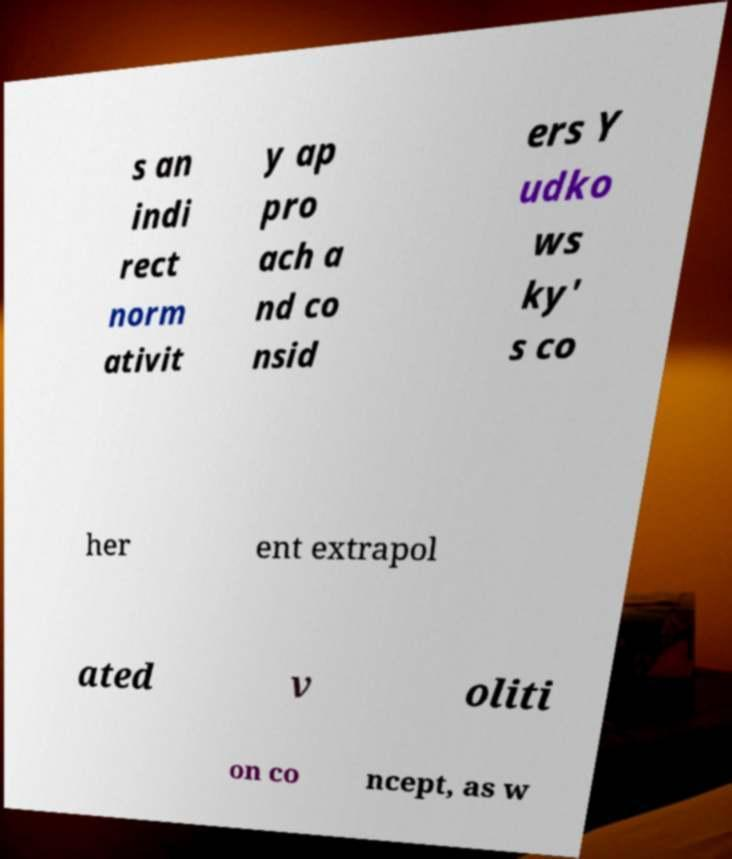What messages or text are displayed in this image? I need them in a readable, typed format. s an indi rect norm ativit y ap pro ach a nd co nsid ers Y udko ws ky' s co her ent extrapol ated v oliti on co ncept, as w 